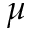<formula> <loc_0><loc_0><loc_500><loc_500>\mu</formula> 